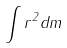<formula> <loc_0><loc_0><loc_500><loc_500>\int r ^ { 2 } d m</formula> 